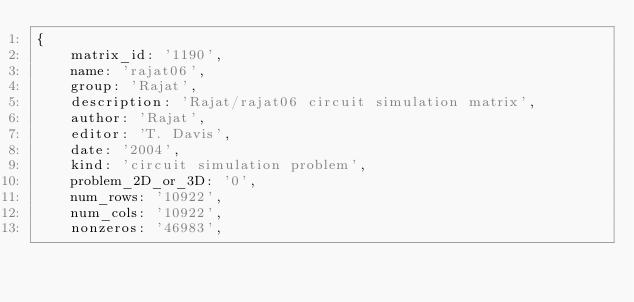Convert code to text. <code><loc_0><loc_0><loc_500><loc_500><_Ruby_>{
    matrix_id: '1190',
    name: 'rajat06',
    group: 'Rajat',
    description: 'Rajat/rajat06 circuit simulation matrix',
    author: 'Rajat',
    editor: 'T. Davis',
    date: '2004',
    kind: 'circuit simulation problem',
    problem_2D_or_3D: '0',
    num_rows: '10922',
    num_cols: '10922',
    nonzeros: '46983',</code> 